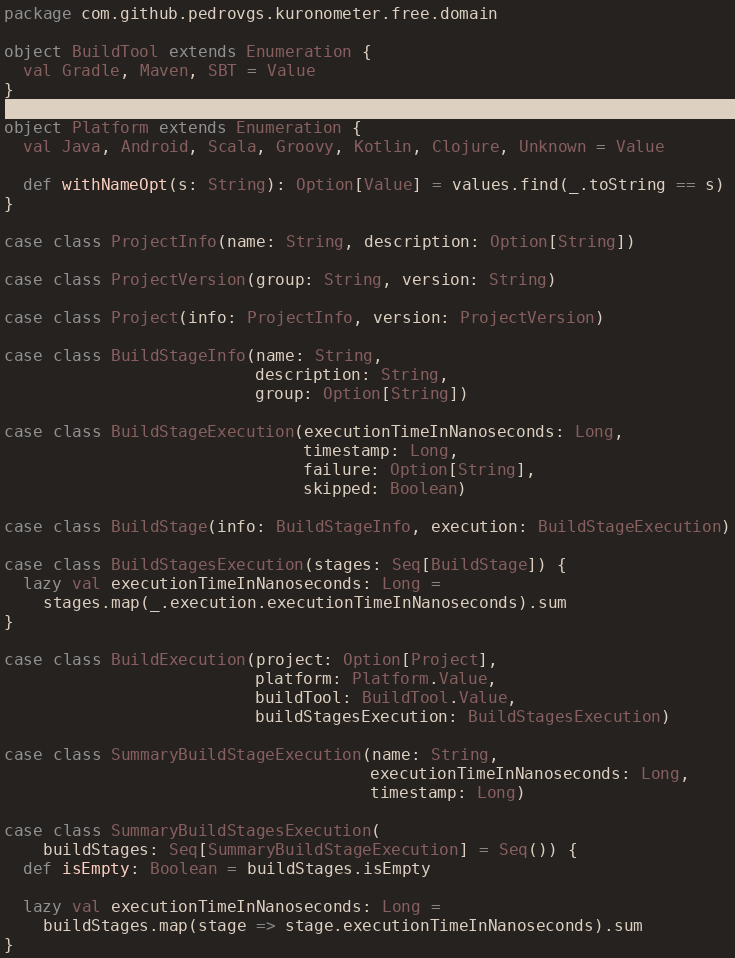<code> <loc_0><loc_0><loc_500><loc_500><_Scala_>package com.github.pedrovgs.kuronometer.free.domain

object BuildTool extends Enumeration {
  val Gradle, Maven, SBT = Value
}

object Platform extends Enumeration {
  val Java, Android, Scala, Groovy, Kotlin, Clojure, Unknown = Value

  def withNameOpt(s: String): Option[Value] = values.find(_.toString == s)
}

case class ProjectInfo(name: String, description: Option[String])

case class ProjectVersion(group: String, version: String)

case class Project(info: ProjectInfo, version: ProjectVersion)

case class BuildStageInfo(name: String,
                          description: String,
                          group: Option[String])

case class BuildStageExecution(executionTimeInNanoseconds: Long,
                               timestamp: Long,
                               failure: Option[String],
                               skipped: Boolean)

case class BuildStage(info: BuildStageInfo, execution: BuildStageExecution)

case class BuildStagesExecution(stages: Seq[BuildStage]) {
  lazy val executionTimeInNanoseconds: Long =
    stages.map(_.execution.executionTimeInNanoseconds).sum
}

case class BuildExecution(project: Option[Project],
                          platform: Platform.Value,
                          buildTool: BuildTool.Value,
                          buildStagesExecution: BuildStagesExecution)

case class SummaryBuildStageExecution(name: String,
                                      executionTimeInNanoseconds: Long,
                                      timestamp: Long)

case class SummaryBuildStagesExecution(
    buildStages: Seq[SummaryBuildStageExecution] = Seq()) {
  def isEmpty: Boolean = buildStages.isEmpty

  lazy val executionTimeInNanoseconds: Long =
    buildStages.map(stage => stage.executionTimeInNanoseconds).sum
}
</code> 